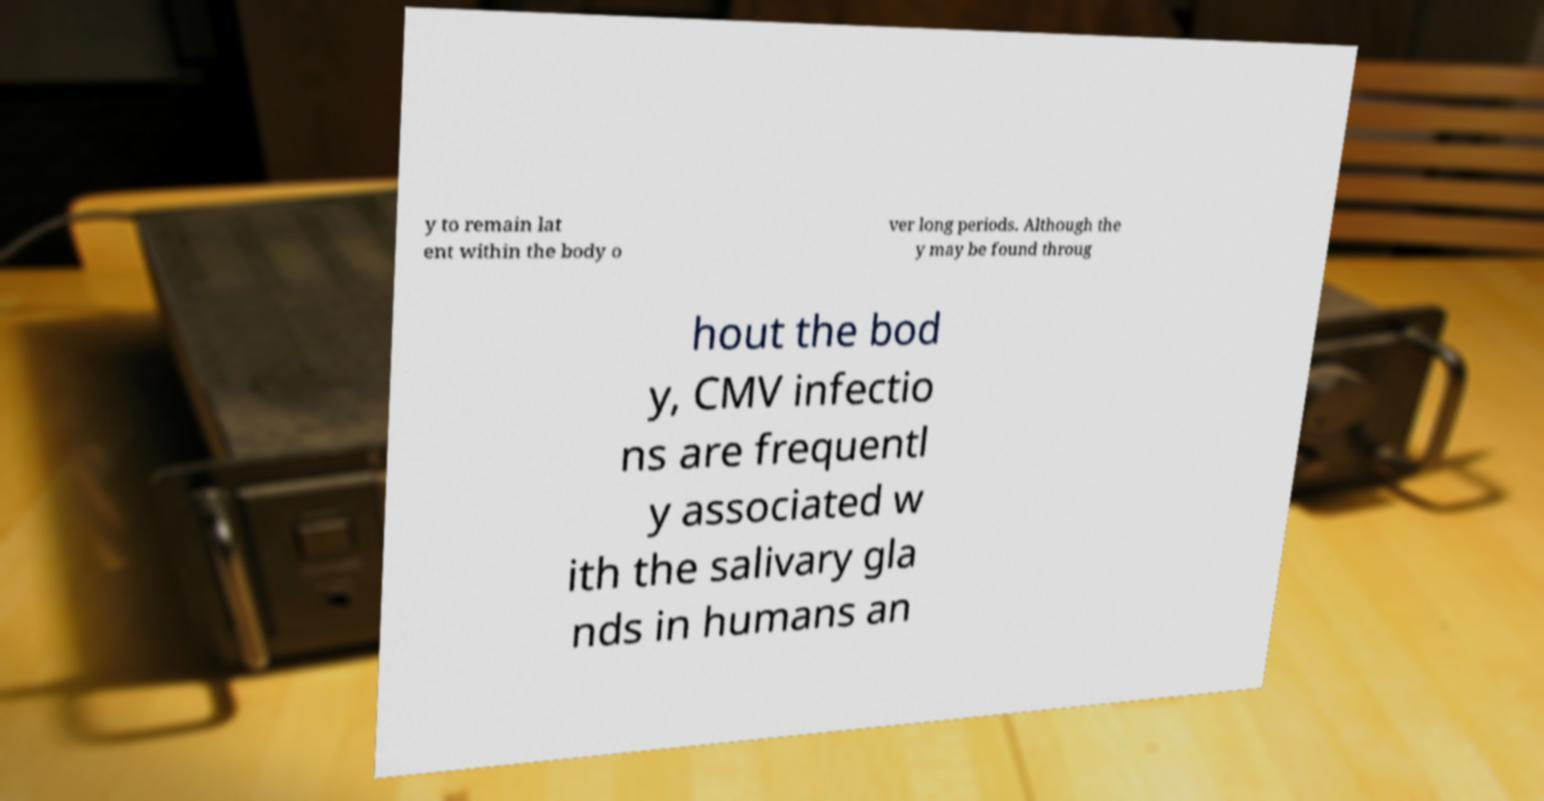For documentation purposes, I need the text within this image transcribed. Could you provide that? y to remain lat ent within the body o ver long periods. Although the y may be found throug hout the bod y, CMV infectio ns are frequentl y associated w ith the salivary gla nds in humans an 